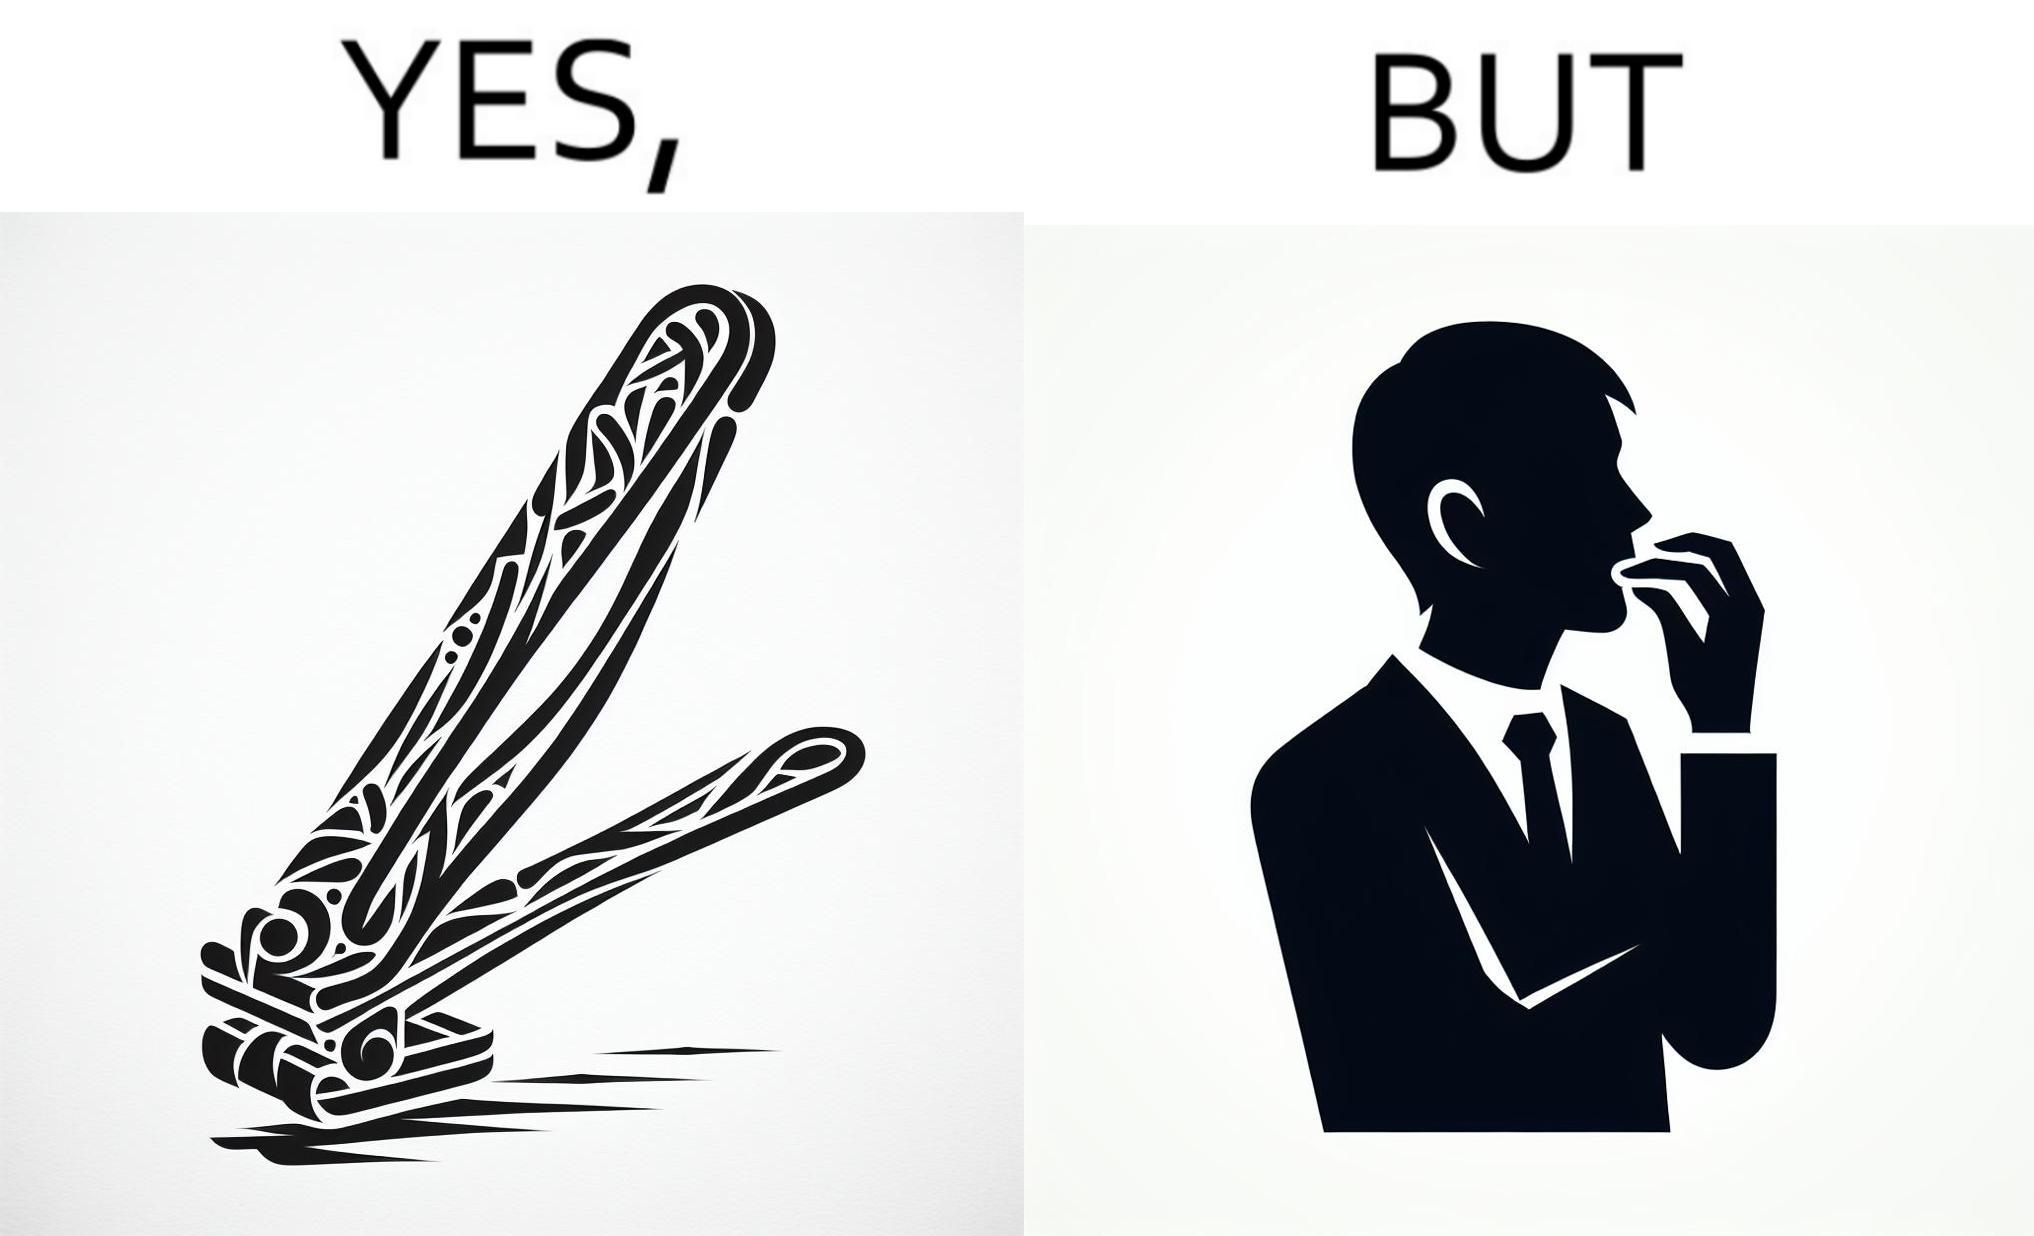Explain the humor or irony in this image. The image is ironic, because even after nail clippers are available people prefer biting their nails by teeth 